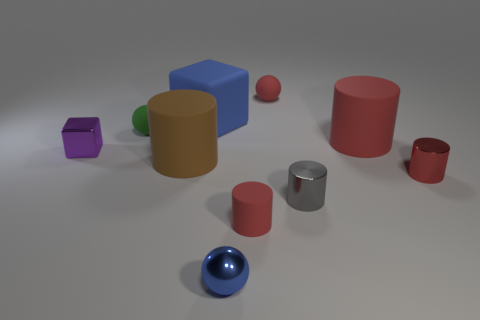Are any tiny metal cylinders visible? Yes, there is one small metal cylinder resting among other variously shaped objects in the scene. It is distinguished by its reflective silver surface and cylindrical shape which contrasts with the surrounding matte-textured items. 